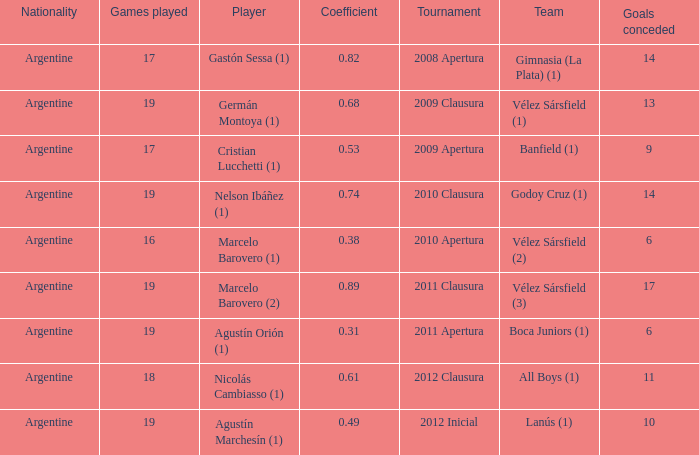What is the coefficient for agustín marchesín (1)? 0.49. 